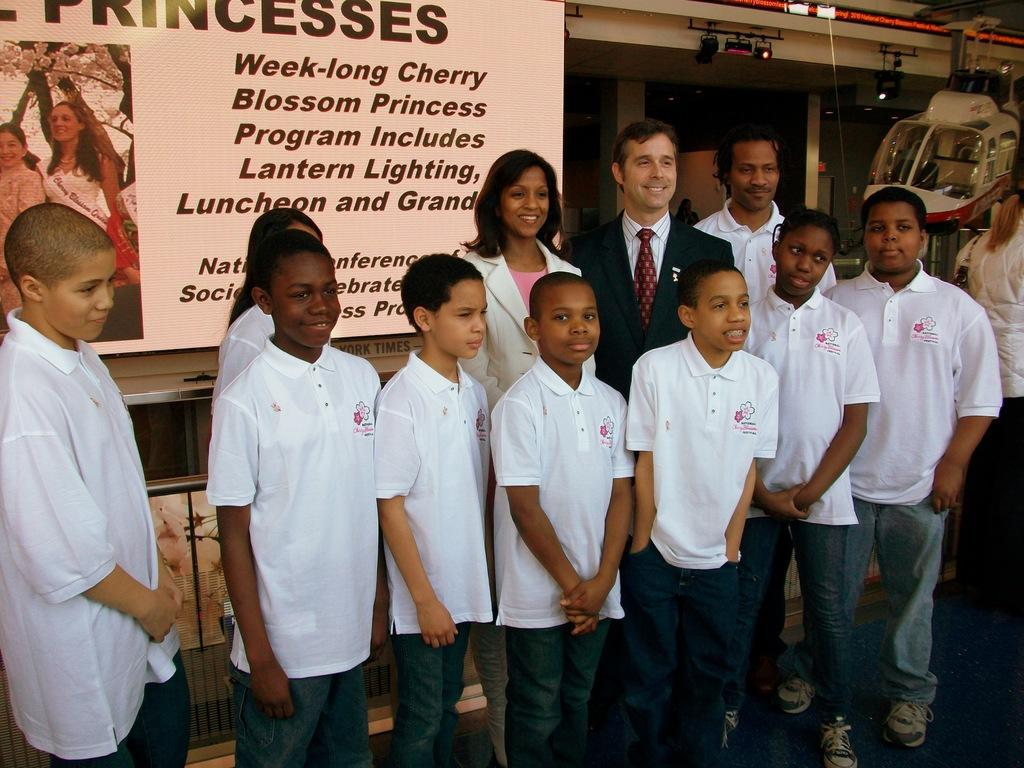How many people are in the image? There is a group of people in the image. What are the people doing in the image? The people are standing on the floor and smiling. What can be seen on the wall in the image? There is a poster visible in the image. What type of lighting is present in the image? There are lights in the image. What can be seen in the background of the image? There are objects in the background of the image. What type of steel is used to construct the snakes in the image? There are no snakes or steel present in the image. How does the stomach of the person in the image feel? There is no information about the stomach of any person in the image. 